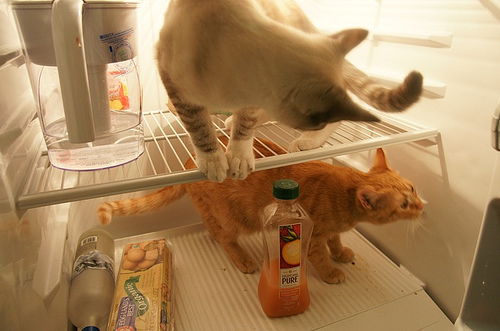Read and extract the text from this image. PURE 